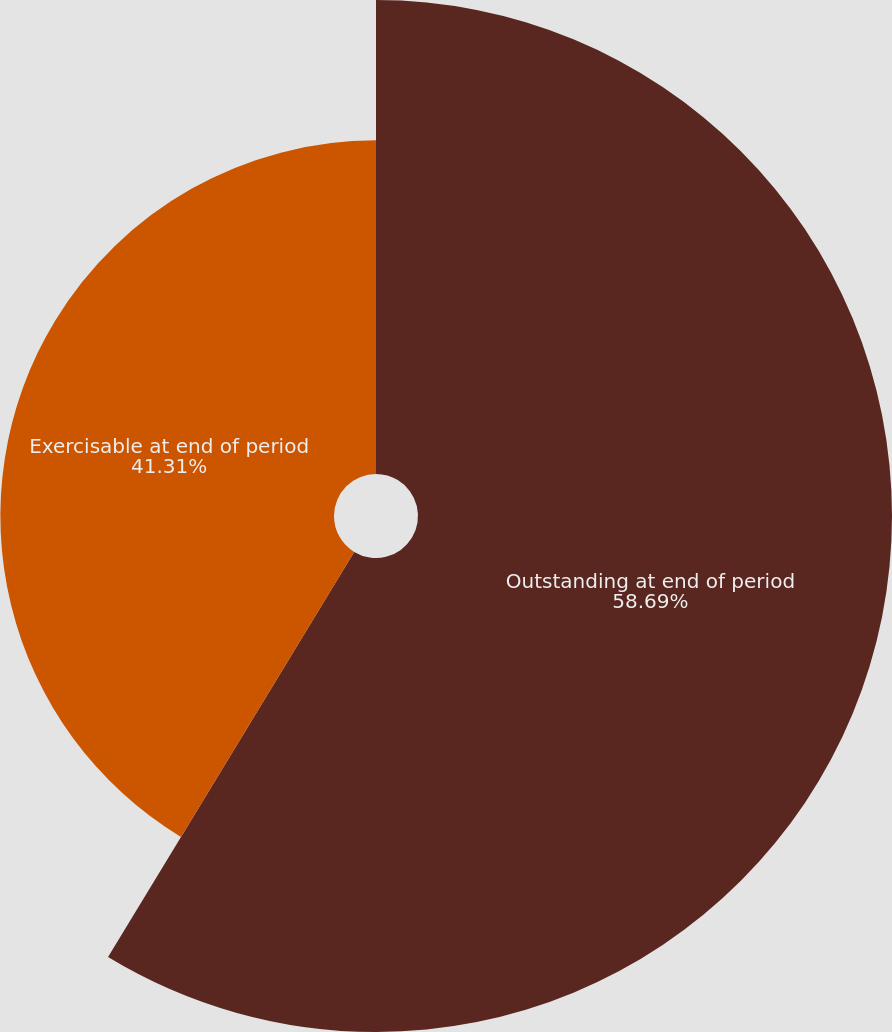Convert chart to OTSL. <chart><loc_0><loc_0><loc_500><loc_500><pie_chart><fcel>Outstanding at end of period<fcel>Exercisable at end of period<nl><fcel>58.69%<fcel>41.31%<nl></chart> 